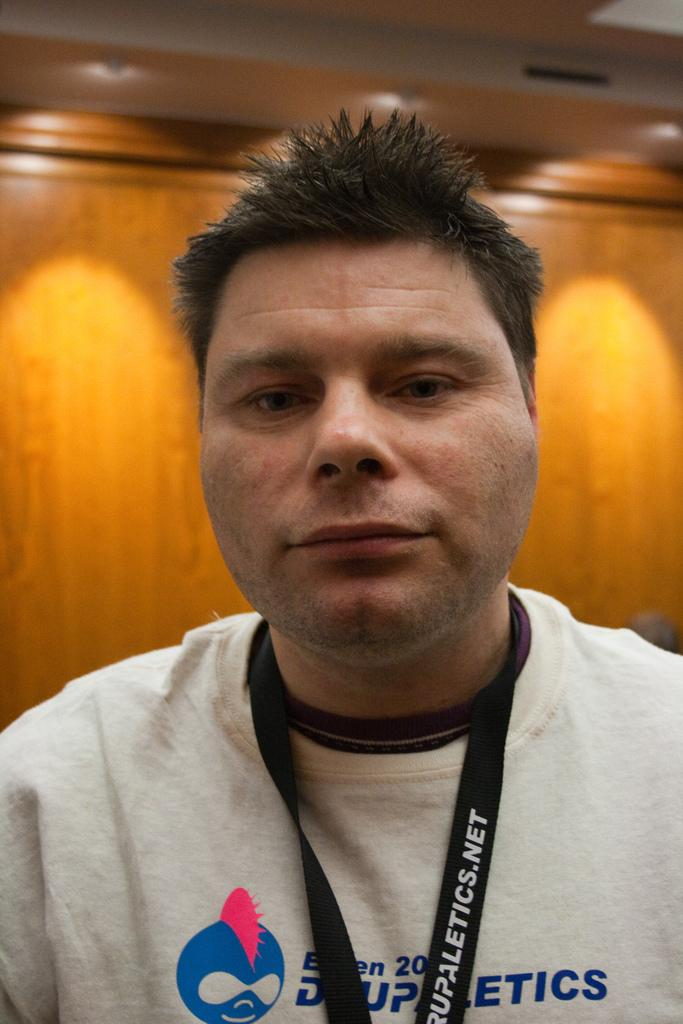<image>
Relay a brief, clear account of the picture shown. A man is wearing a lanyard that has a URL on it that ends with net. 